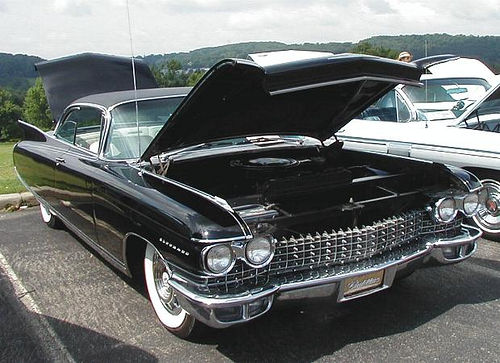Is there sufficient lighting in the image?
A. Yes
B. Dim
C. No
D. Insufficient
Answer with the option's letter from the given choices directly.
 A. 